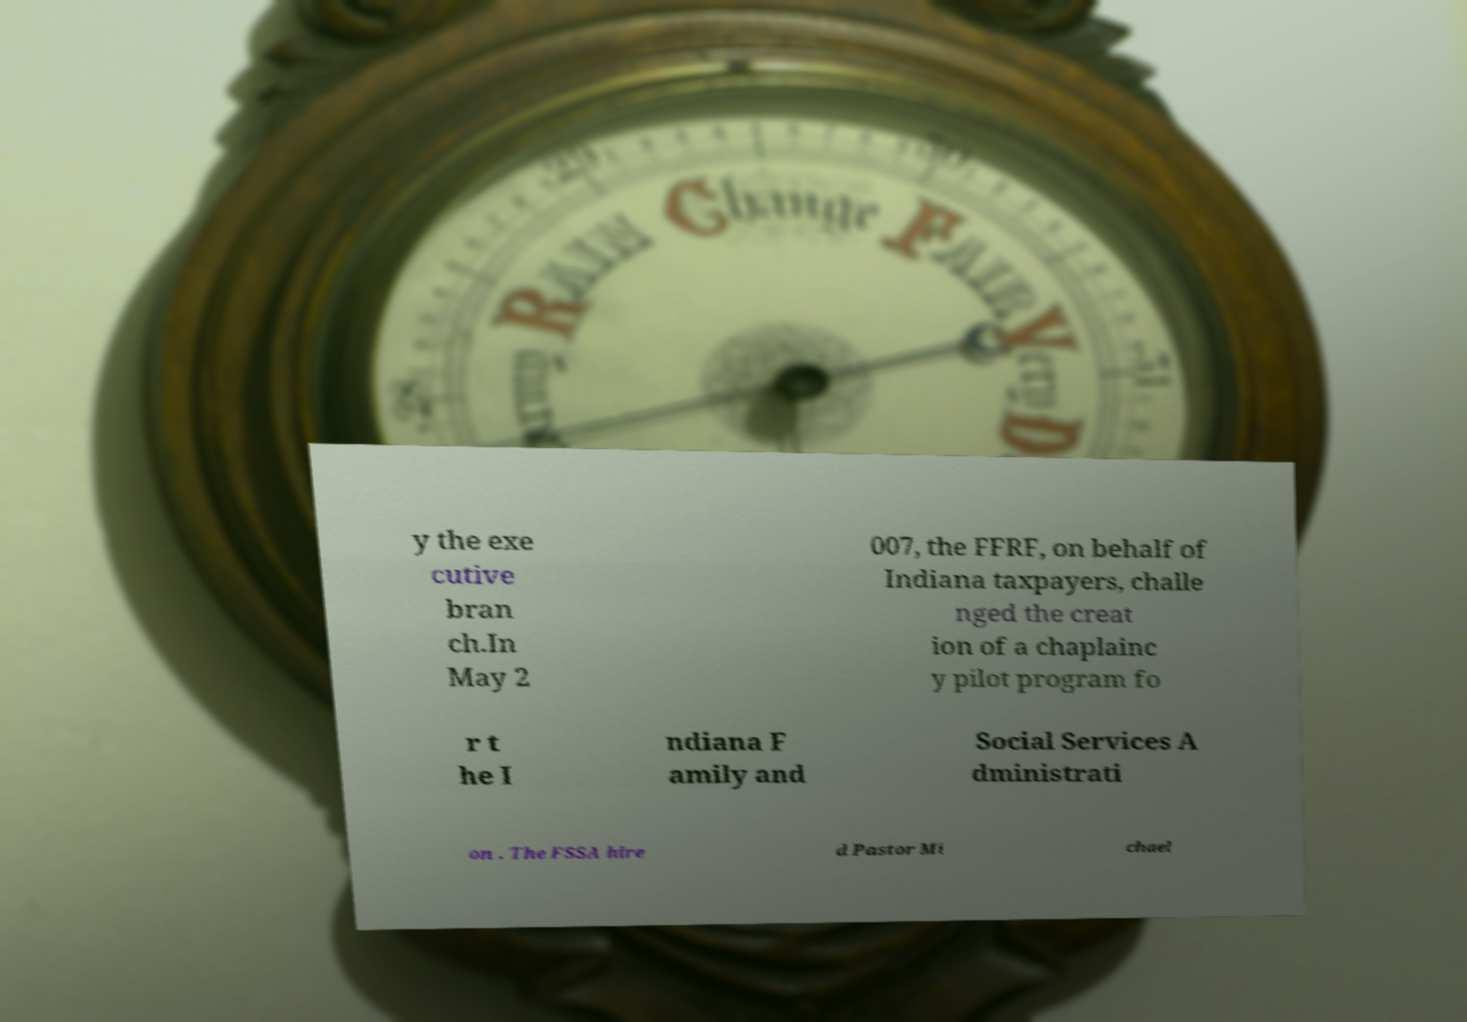Could you extract and type out the text from this image? y the exe cutive bran ch.In May 2 007, the FFRF, on behalf of Indiana taxpayers, challe nged the creat ion of a chaplainc y pilot program fo r t he I ndiana F amily and Social Services A dministrati on . The FSSA hire d Pastor Mi chael 